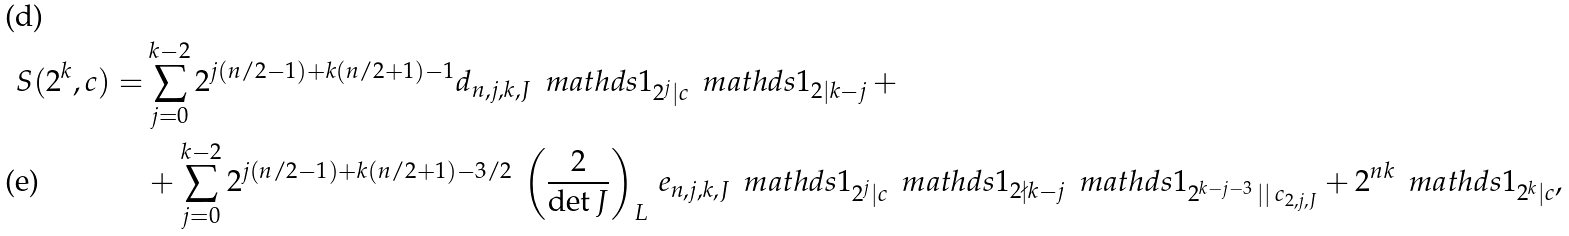<formula> <loc_0><loc_0><loc_500><loc_500>S ( 2 ^ { k } , c ) = & \sum _ { j = 0 } ^ { k - 2 } 2 ^ { j ( n / 2 - 1 ) + k ( n / 2 + 1 ) - 1 } d _ { n , j , k , J } \, \ m a t h d s { 1 } _ { 2 ^ { j } | c } \, \ m a t h d s { 1 } _ { 2 | k - j } \, + \\ & + \sum _ { j = 0 } ^ { k - 2 } 2 ^ { j ( n / 2 - 1 ) + k ( n / 2 + 1 ) - 3 / 2 } \, \left ( \frac { 2 } { \det J } \right ) _ { L } \, e _ { n , j , k , J } \, \ m a t h d s { 1 } _ { 2 ^ { j } | c } \, \ m a t h d s { 1 } _ { 2 \nmid k - j } \, \ m a t h d s { 1 } _ { 2 ^ { k - j - 3 } \, | | \, c _ { 2 , j , J } } + 2 ^ { n k } \, \ m a t h d s { 1 } _ { 2 ^ { k } | c } ,</formula> 